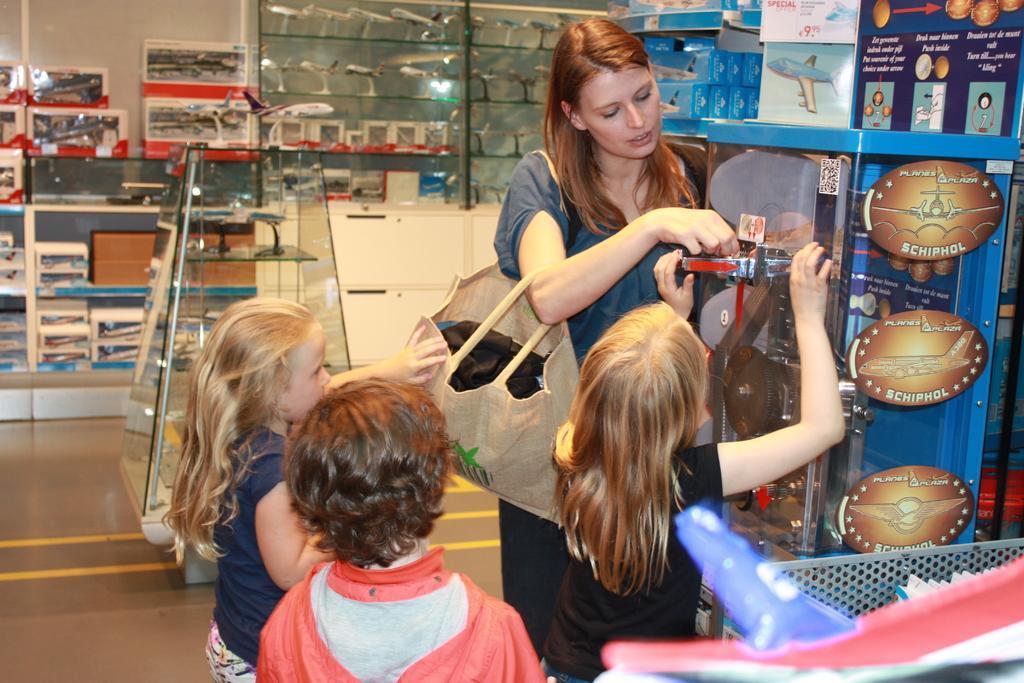Could you give a brief overview of what you see in this image? In this picture there is a woman and a kid holding an object in front of them and there are two other kids behind them and there are few toys in the background. 